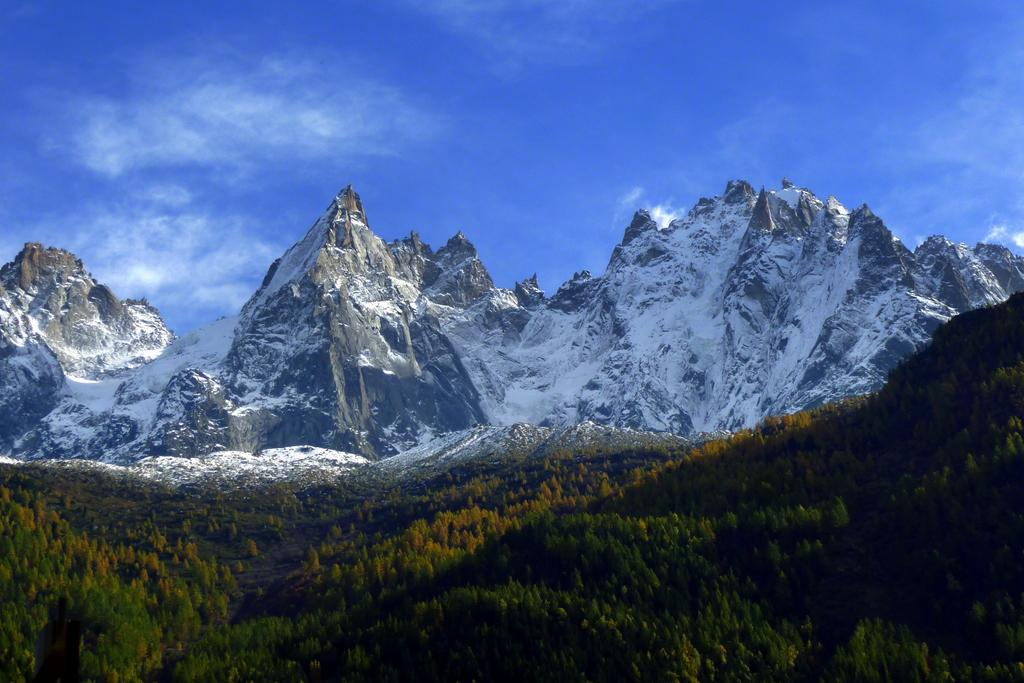What type of vegetation or plants can be seen at the bottom of the image? There is greenery at the bottom of the image. What natural features are visible in the background? Mountains and the sky are visible in the background. Can you describe the condition of the mountains? It appears that there is snow on the mountains. How does the cream affect the deer in the image? There are no deer or cream present in the image. What is the cause of the snow on the mountains in the image? The cause of the snow on the mountains is not visible or mentioned in the image; it is a natural occurrence due to cold temperatures and weather conditions. 